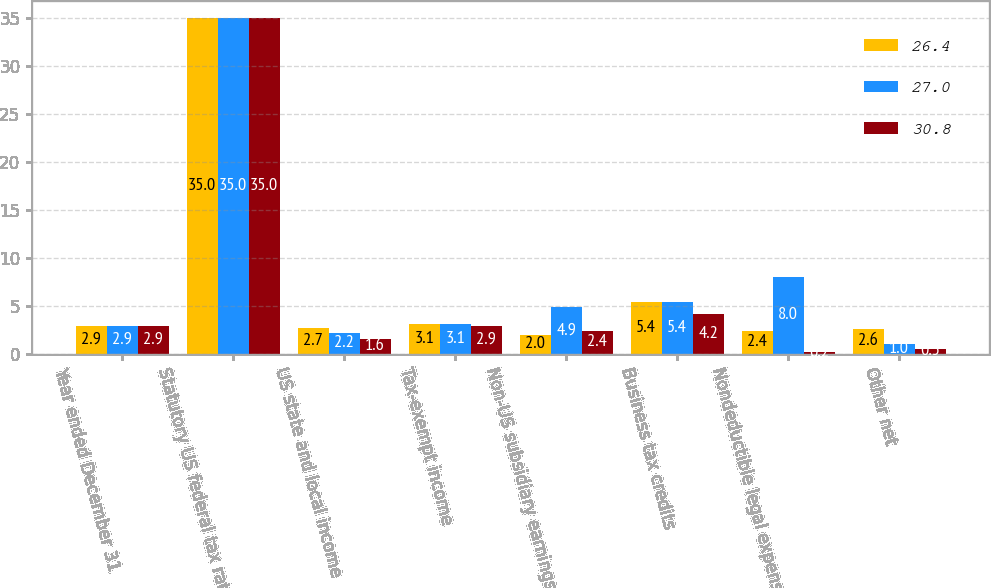Convert chart. <chart><loc_0><loc_0><loc_500><loc_500><stacked_bar_chart><ecel><fcel>Year ended December 31<fcel>Statutory US federal tax rate<fcel>US state and local income<fcel>Tax-exempt income<fcel>Non-US subsidiary earnings (a)<fcel>Business tax credits<fcel>Nondeductible legal expense<fcel>Other net<nl><fcel>26.4<fcel>2.9<fcel>35<fcel>2.7<fcel>3.1<fcel>2<fcel>5.4<fcel>2.4<fcel>2.6<nl><fcel>27<fcel>2.9<fcel>35<fcel>2.2<fcel>3.1<fcel>4.9<fcel>5.4<fcel>8<fcel>1<nl><fcel>30.8<fcel>2.9<fcel>35<fcel>1.6<fcel>2.9<fcel>2.4<fcel>4.2<fcel>0.2<fcel>0.5<nl></chart> 